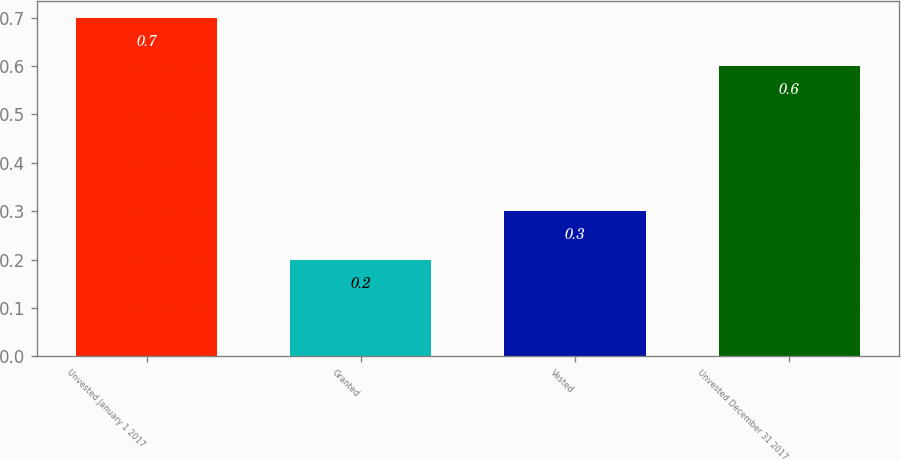Convert chart. <chart><loc_0><loc_0><loc_500><loc_500><bar_chart><fcel>Unvested January 1 2017<fcel>Granted<fcel>Vested<fcel>Unvested December 31 2017<nl><fcel>0.7<fcel>0.2<fcel>0.3<fcel>0.6<nl></chart> 